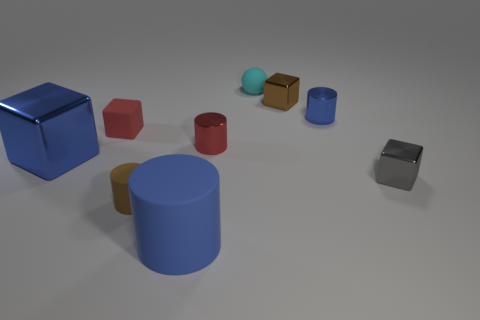There is a thing that is both on the right side of the cyan sphere and behind the blue shiny cylinder; how big is it?
Make the answer very short. Small. Are there fewer small gray spheres than small brown shiny blocks?
Your answer should be very brief. Yes. How big is the matte cylinder in front of the tiny brown matte object?
Keep it short and to the point. Large. There is a rubber object that is on the right side of the small red block and behind the red cylinder; what is its shape?
Your response must be concise. Sphere. What size is the matte thing that is the same shape as the tiny brown metallic thing?
Your answer should be very brief. Small. How many other big yellow cylinders have the same material as the big cylinder?
Your answer should be very brief. 0. There is a big cube; is its color the same as the rubber thing that is in front of the small brown cylinder?
Offer a terse response. Yes. Are there more small metal objects than small red spheres?
Offer a very short reply. Yes. What is the color of the small sphere?
Your response must be concise. Cyan. There is a small cube that is right of the brown shiny block; is its color the same as the small matte block?
Your response must be concise. No. 